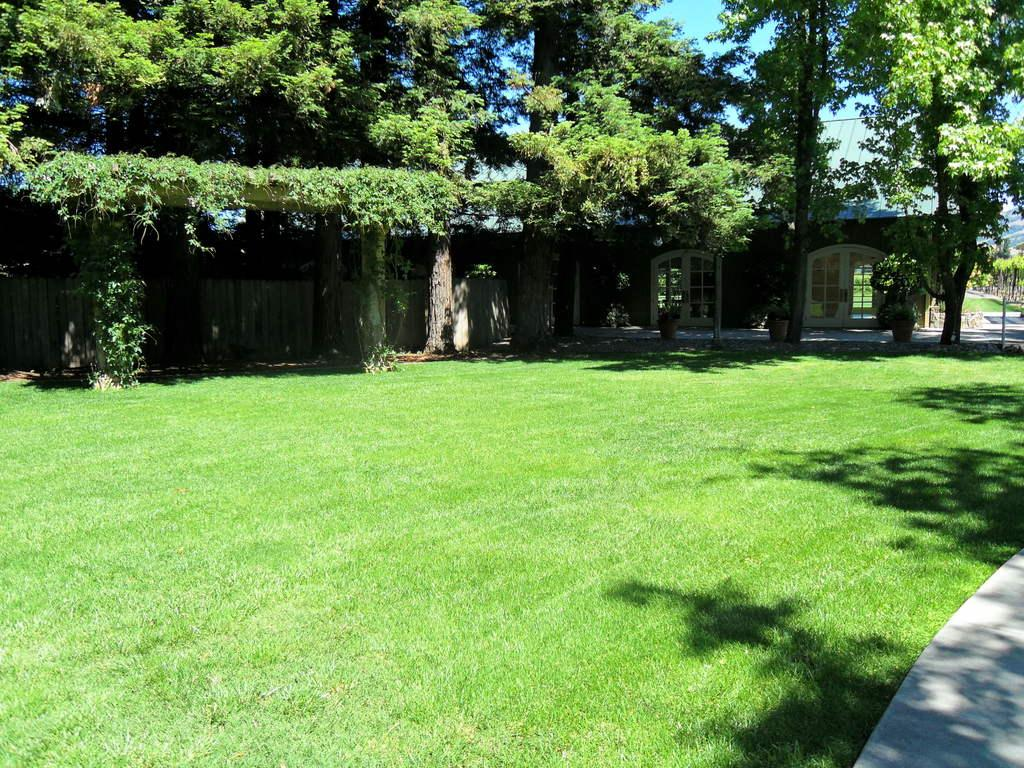What type of vegetation is present on the ground in the image? There is grass on the ground in the image. What other natural elements can be seen in the image? There are trees in the image. What type of structure is visible in the image? There is a wooden wall in the image. What is visible in the background of the image? The sky is visible in the background of the image. How many cherries are hanging from the wooden wall in the image? There are no cherries present in the image; it features grass, trees, a wooden wall, and the sky. 